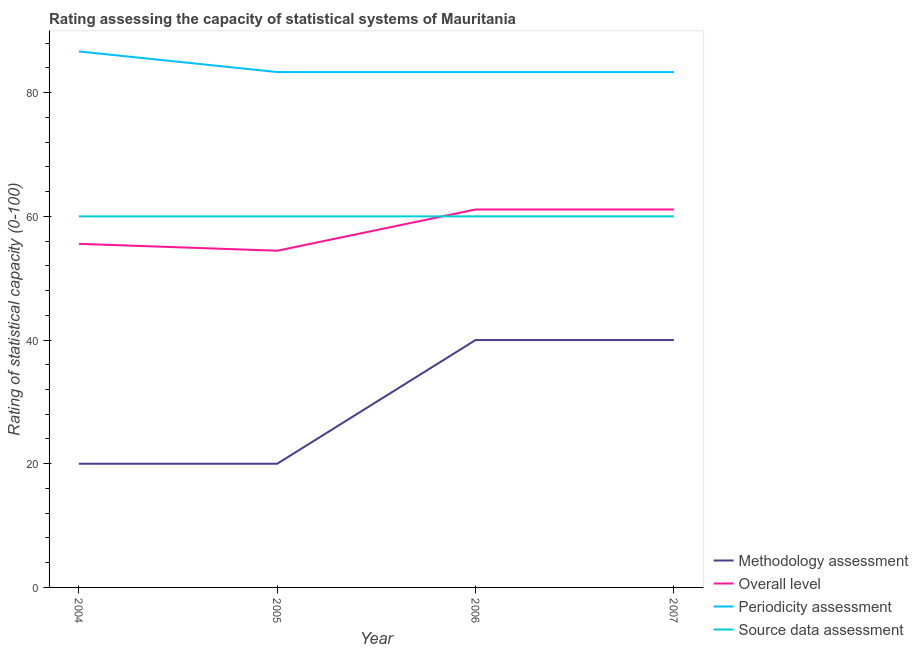How many different coloured lines are there?
Make the answer very short. 4. Does the line corresponding to methodology assessment rating intersect with the line corresponding to periodicity assessment rating?
Keep it short and to the point. No. What is the methodology assessment rating in 2005?
Offer a very short reply. 20. Across all years, what is the maximum source data assessment rating?
Offer a very short reply. 60. Across all years, what is the minimum source data assessment rating?
Your answer should be compact. 60. In which year was the source data assessment rating maximum?
Offer a terse response. 2004. What is the total overall level rating in the graph?
Ensure brevity in your answer.  232.22. What is the difference between the overall level rating in 2004 and that in 2006?
Your response must be concise. -5.56. What is the difference between the periodicity assessment rating in 2006 and the methodology assessment rating in 2005?
Your answer should be compact. 63.33. In the year 2006, what is the difference between the periodicity assessment rating and methodology assessment rating?
Ensure brevity in your answer.  43.33. What is the ratio of the overall level rating in 2005 to that in 2007?
Offer a terse response. 0.89. Is the periodicity assessment rating in 2005 less than that in 2006?
Provide a short and direct response. No. What is the difference between the highest and the second highest overall level rating?
Your response must be concise. 0. In how many years, is the source data assessment rating greater than the average source data assessment rating taken over all years?
Your answer should be compact. 0. Is the sum of the overall level rating in 2004 and 2006 greater than the maximum source data assessment rating across all years?
Your answer should be very brief. Yes. Is it the case that in every year, the sum of the overall level rating and methodology assessment rating is greater than the sum of periodicity assessment rating and source data assessment rating?
Make the answer very short. No. Does the periodicity assessment rating monotonically increase over the years?
Offer a terse response. No. How many lines are there?
Your answer should be very brief. 4. How many years are there in the graph?
Provide a short and direct response. 4. What is the difference between two consecutive major ticks on the Y-axis?
Give a very brief answer. 20. Does the graph contain any zero values?
Your response must be concise. No. Where does the legend appear in the graph?
Your answer should be compact. Bottom right. How many legend labels are there?
Provide a short and direct response. 4. What is the title of the graph?
Provide a short and direct response. Rating assessing the capacity of statistical systems of Mauritania. What is the label or title of the Y-axis?
Your answer should be very brief. Rating of statistical capacity (0-100). What is the Rating of statistical capacity (0-100) in Methodology assessment in 2004?
Ensure brevity in your answer.  20. What is the Rating of statistical capacity (0-100) of Overall level in 2004?
Your answer should be compact. 55.56. What is the Rating of statistical capacity (0-100) in Periodicity assessment in 2004?
Provide a succinct answer. 86.67. What is the Rating of statistical capacity (0-100) of Overall level in 2005?
Offer a very short reply. 54.44. What is the Rating of statistical capacity (0-100) of Periodicity assessment in 2005?
Offer a terse response. 83.33. What is the Rating of statistical capacity (0-100) in Methodology assessment in 2006?
Offer a very short reply. 40. What is the Rating of statistical capacity (0-100) in Overall level in 2006?
Keep it short and to the point. 61.11. What is the Rating of statistical capacity (0-100) in Periodicity assessment in 2006?
Offer a very short reply. 83.33. What is the Rating of statistical capacity (0-100) in Overall level in 2007?
Give a very brief answer. 61.11. What is the Rating of statistical capacity (0-100) in Periodicity assessment in 2007?
Make the answer very short. 83.33. Across all years, what is the maximum Rating of statistical capacity (0-100) of Methodology assessment?
Provide a succinct answer. 40. Across all years, what is the maximum Rating of statistical capacity (0-100) of Overall level?
Provide a short and direct response. 61.11. Across all years, what is the maximum Rating of statistical capacity (0-100) in Periodicity assessment?
Offer a very short reply. 86.67. Across all years, what is the minimum Rating of statistical capacity (0-100) of Methodology assessment?
Ensure brevity in your answer.  20. Across all years, what is the minimum Rating of statistical capacity (0-100) in Overall level?
Offer a very short reply. 54.44. Across all years, what is the minimum Rating of statistical capacity (0-100) in Periodicity assessment?
Offer a very short reply. 83.33. What is the total Rating of statistical capacity (0-100) in Methodology assessment in the graph?
Make the answer very short. 120. What is the total Rating of statistical capacity (0-100) in Overall level in the graph?
Your answer should be very brief. 232.22. What is the total Rating of statistical capacity (0-100) in Periodicity assessment in the graph?
Offer a very short reply. 336.67. What is the total Rating of statistical capacity (0-100) of Source data assessment in the graph?
Offer a terse response. 240. What is the difference between the Rating of statistical capacity (0-100) of Methodology assessment in 2004 and that in 2005?
Provide a short and direct response. 0. What is the difference between the Rating of statistical capacity (0-100) of Periodicity assessment in 2004 and that in 2005?
Make the answer very short. 3.33. What is the difference between the Rating of statistical capacity (0-100) of Methodology assessment in 2004 and that in 2006?
Your answer should be very brief. -20. What is the difference between the Rating of statistical capacity (0-100) of Overall level in 2004 and that in 2006?
Provide a short and direct response. -5.56. What is the difference between the Rating of statistical capacity (0-100) in Periodicity assessment in 2004 and that in 2006?
Ensure brevity in your answer.  3.33. What is the difference between the Rating of statistical capacity (0-100) in Source data assessment in 2004 and that in 2006?
Offer a very short reply. 0. What is the difference between the Rating of statistical capacity (0-100) of Methodology assessment in 2004 and that in 2007?
Provide a short and direct response. -20. What is the difference between the Rating of statistical capacity (0-100) in Overall level in 2004 and that in 2007?
Provide a succinct answer. -5.56. What is the difference between the Rating of statistical capacity (0-100) in Source data assessment in 2004 and that in 2007?
Your response must be concise. 0. What is the difference between the Rating of statistical capacity (0-100) in Methodology assessment in 2005 and that in 2006?
Keep it short and to the point. -20. What is the difference between the Rating of statistical capacity (0-100) in Overall level in 2005 and that in 2006?
Give a very brief answer. -6.67. What is the difference between the Rating of statistical capacity (0-100) in Overall level in 2005 and that in 2007?
Your answer should be compact. -6.67. What is the difference between the Rating of statistical capacity (0-100) in Periodicity assessment in 2005 and that in 2007?
Your response must be concise. 0. What is the difference between the Rating of statistical capacity (0-100) of Methodology assessment in 2006 and that in 2007?
Ensure brevity in your answer.  0. What is the difference between the Rating of statistical capacity (0-100) in Overall level in 2006 and that in 2007?
Offer a terse response. 0. What is the difference between the Rating of statistical capacity (0-100) of Methodology assessment in 2004 and the Rating of statistical capacity (0-100) of Overall level in 2005?
Keep it short and to the point. -34.44. What is the difference between the Rating of statistical capacity (0-100) in Methodology assessment in 2004 and the Rating of statistical capacity (0-100) in Periodicity assessment in 2005?
Give a very brief answer. -63.33. What is the difference between the Rating of statistical capacity (0-100) of Overall level in 2004 and the Rating of statistical capacity (0-100) of Periodicity assessment in 2005?
Provide a short and direct response. -27.78. What is the difference between the Rating of statistical capacity (0-100) of Overall level in 2004 and the Rating of statistical capacity (0-100) of Source data assessment in 2005?
Your answer should be compact. -4.44. What is the difference between the Rating of statistical capacity (0-100) in Periodicity assessment in 2004 and the Rating of statistical capacity (0-100) in Source data assessment in 2005?
Make the answer very short. 26.67. What is the difference between the Rating of statistical capacity (0-100) of Methodology assessment in 2004 and the Rating of statistical capacity (0-100) of Overall level in 2006?
Offer a very short reply. -41.11. What is the difference between the Rating of statistical capacity (0-100) of Methodology assessment in 2004 and the Rating of statistical capacity (0-100) of Periodicity assessment in 2006?
Keep it short and to the point. -63.33. What is the difference between the Rating of statistical capacity (0-100) of Methodology assessment in 2004 and the Rating of statistical capacity (0-100) of Source data assessment in 2006?
Give a very brief answer. -40. What is the difference between the Rating of statistical capacity (0-100) of Overall level in 2004 and the Rating of statistical capacity (0-100) of Periodicity assessment in 2006?
Your response must be concise. -27.78. What is the difference between the Rating of statistical capacity (0-100) of Overall level in 2004 and the Rating of statistical capacity (0-100) of Source data assessment in 2006?
Provide a short and direct response. -4.44. What is the difference between the Rating of statistical capacity (0-100) in Periodicity assessment in 2004 and the Rating of statistical capacity (0-100) in Source data assessment in 2006?
Your answer should be very brief. 26.67. What is the difference between the Rating of statistical capacity (0-100) of Methodology assessment in 2004 and the Rating of statistical capacity (0-100) of Overall level in 2007?
Make the answer very short. -41.11. What is the difference between the Rating of statistical capacity (0-100) of Methodology assessment in 2004 and the Rating of statistical capacity (0-100) of Periodicity assessment in 2007?
Provide a succinct answer. -63.33. What is the difference between the Rating of statistical capacity (0-100) in Overall level in 2004 and the Rating of statistical capacity (0-100) in Periodicity assessment in 2007?
Your answer should be compact. -27.78. What is the difference between the Rating of statistical capacity (0-100) of Overall level in 2004 and the Rating of statistical capacity (0-100) of Source data assessment in 2007?
Your response must be concise. -4.44. What is the difference between the Rating of statistical capacity (0-100) in Periodicity assessment in 2004 and the Rating of statistical capacity (0-100) in Source data assessment in 2007?
Offer a terse response. 26.67. What is the difference between the Rating of statistical capacity (0-100) in Methodology assessment in 2005 and the Rating of statistical capacity (0-100) in Overall level in 2006?
Offer a terse response. -41.11. What is the difference between the Rating of statistical capacity (0-100) in Methodology assessment in 2005 and the Rating of statistical capacity (0-100) in Periodicity assessment in 2006?
Make the answer very short. -63.33. What is the difference between the Rating of statistical capacity (0-100) of Overall level in 2005 and the Rating of statistical capacity (0-100) of Periodicity assessment in 2006?
Give a very brief answer. -28.89. What is the difference between the Rating of statistical capacity (0-100) in Overall level in 2005 and the Rating of statistical capacity (0-100) in Source data assessment in 2006?
Your response must be concise. -5.56. What is the difference between the Rating of statistical capacity (0-100) in Periodicity assessment in 2005 and the Rating of statistical capacity (0-100) in Source data assessment in 2006?
Keep it short and to the point. 23.33. What is the difference between the Rating of statistical capacity (0-100) in Methodology assessment in 2005 and the Rating of statistical capacity (0-100) in Overall level in 2007?
Your response must be concise. -41.11. What is the difference between the Rating of statistical capacity (0-100) in Methodology assessment in 2005 and the Rating of statistical capacity (0-100) in Periodicity assessment in 2007?
Your response must be concise. -63.33. What is the difference between the Rating of statistical capacity (0-100) in Overall level in 2005 and the Rating of statistical capacity (0-100) in Periodicity assessment in 2007?
Your response must be concise. -28.89. What is the difference between the Rating of statistical capacity (0-100) in Overall level in 2005 and the Rating of statistical capacity (0-100) in Source data assessment in 2007?
Offer a very short reply. -5.56. What is the difference between the Rating of statistical capacity (0-100) in Periodicity assessment in 2005 and the Rating of statistical capacity (0-100) in Source data assessment in 2007?
Make the answer very short. 23.33. What is the difference between the Rating of statistical capacity (0-100) in Methodology assessment in 2006 and the Rating of statistical capacity (0-100) in Overall level in 2007?
Your answer should be compact. -21.11. What is the difference between the Rating of statistical capacity (0-100) in Methodology assessment in 2006 and the Rating of statistical capacity (0-100) in Periodicity assessment in 2007?
Provide a short and direct response. -43.33. What is the difference between the Rating of statistical capacity (0-100) in Methodology assessment in 2006 and the Rating of statistical capacity (0-100) in Source data assessment in 2007?
Provide a succinct answer. -20. What is the difference between the Rating of statistical capacity (0-100) of Overall level in 2006 and the Rating of statistical capacity (0-100) of Periodicity assessment in 2007?
Make the answer very short. -22.22. What is the difference between the Rating of statistical capacity (0-100) of Overall level in 2006 and the Rating of statistical capacity (0-100) of Source data assessment in 2007?
Your answer should be very brief. 1.11. What is the difference between the Rating of statistical capacity (0-100) in Periodicity assessment in 2006 and the Rating of statistical capacity (0-100) in Source data assessment in 2007?
Provide a succinct answer. 23.33. What is the average Rating of statistical capacity (0-100) of Overall level per year?
Your answer should be very brief. 58.06. What is the average Rating of statistical capacity (0-100) in Periodicity assessment per year?
Your answer should be very brief. 84.17. In the year 2004, what is the difference between the Rating of statistical capacity (0-100) of Methodology assessment and Rating of statistical capacity (0-100) of Overall level?
Offer a terse response. -35.56. In the year 2004, what is the difference between the Rating of statistical capacity (0-100) of Methodology assessment and Rating of statistical capacity (0-100) of Periodicity assessment?
Your answer should be compact. -66.67. In the year 2004, what is the difference between the Rating of statistical capacity (0-100) in Methodology assessment and Rating of statistical capacity (0-100) in Source data assessment?
Offer a very short reply. -40. In the year 2004, what is the difference between the Rating of statistical capacity (0-100) in Overall level and Rating of statistical capacity (0-100) in Periodicity assessment?
Your response must be concise. -31.11. In the year 2004, what is the difference between the Rating of statistical capacity (0-100) of Overall level and Rating of statistical capacity (0-100) of Source data assessment?
Offer a terse response. -4.44. In the year 2004, what is the difference between the Rating of statistical capacity (0-100) of Periodicity assessment and Rating of statistical capacity (0-100) of Source data assessment?
Provide a succinct answer. 26.67. In the year 2005, what is the difference between the Rating of statistical capacity (0-100) of Methodology assessment and Rating of statistical capacity (0-100) of Overall level?
Your answer should be very brief. -34.44. In the year 2005, what is the difference between the Rating of statistical capacity (0-100) in Methodology assessment and Rating of statistical capacity (0-100) in Periodicity assessment?
Your response must be concise. -63.33. In the year 2005, what is the difference between the Rating of statistical capacity (0-100) of Overall level and Rating of statistical capacity (0-100) of Periodicity assessment?
Your answer should be very brief. -28.89. In the year 2005, what is the difference between the Rating of statistical capacity (0-100) in Overall level and Rating of statistical capacity (0-100) in Source data assessment?
Ensure brevity in your answer.  -5.56. In the year 2005, what is the difference between the Rating of statistical capacity (0-100) of Periodicity assessment and Rating of statistical capacity (0-100) of Source data assessment?
Keep it short and to the point. 23.33. In the year 2006, what is the difference between the Rating of statistical capacity (0-100) in Methodology assessment and Rating of statistical capacity (0-100) in Overall level?
Keep it short and to the point. -21.11. In the year 2006, what is the difference between the Rating of statistical capacity (0-100) of Methodology assessment and Rating of statistical capacity (0-100) of Periodicity assessment?
Provide a succinct answer. -43.33. In the year 2006, what is the difference between the Rating of statistical capacity (0-100) of Methodology assessment and Rating of statistical capacity (0-100) of Source data assessment?
Keep it short and to the point. -20. In the year 2006, what is the difference between the Rating of statistical capacity (0-100) of Overall level and Rating of statistical capacity (0-100) of Periodicity assessment?
Make the answer very short. -22.22. In the year 2006, what is the difference between the Rating of statistical capacity (0-100) in Overall level and Rating of statistical capacity (0-100) in Source data assessment?
Keep it short and to the point. 1.11. In the year 2006, what is the difference between the Rating of statistical capacity (0-100) in Periodicity assessment and Rating of statistical capacity (0-100) in Source data assessment?
Give a very brief answer. 23.33. In the year 2007, what is the difference between the Rating of statistical capacity (0-100) in Methodology assessment and Rating of statistical capacity (0-100) in Overall level?
Ensure brevity in your answer.  -21.11. In the year 2007, what is the difference between the Rating of statistical capacity (0-100) of Methodology assessment and Rating of statistical capacity (0-100) of Periodicity assessment?
Give a very brief answer. -43.33. In the year 2007, what is the difference between the Rating of statistical capacity (0-100) in Methodology assessment and Rating of statistical capacity (0-100) in Source data assessment?
Your response must be concise. -20. In the year 2007, what is the difference between the Rating of statistical capacity (0-100) in Overall level and Rating of statistical capacity (0-100) in Periodicity assessment?
Your response must be concise. -22.22. In the year 2007, what is the difference between the Rating of statistical capacity (0-100) in Periodicity assessment and Rating of statistical capacity (0-100) in Source data assessment?
Your answer should be compact. 23.33. What is the ratio of the Rating of statistical capacity (0-100) of Overall level in 2004 to that in 2005?
Offer a very short reply. 1.02. What is the ratio of the Rating of statistical capacity (0-100) of Periodicity assessment in 2004 to that in 2005?
Your answer should be compact. 1.04. What is the ratio of the Rating of statistical capacity (0-100) in Methodology assessment in 2004 to that in 2006?
Your answer should be compact. 0.5. What is the ratio of the Rating of statistical capacity (0-100) of Source data assessment in 2004 to that in 2006?
Provide a short and direct response. 1. What is the ratio of the Rating of statistical capacity (0-100) of Methodology assessment in 2004 to that in 2007?
Ensure brevity in your answer.  0.5. What is the ratio of the Rating of statistical capacity (0-100) of Periodicity assessment in 2004 to that in 2007?
Make the answer very short. 1.04. What is the ratio of the Rating of statistical capacity (0-100) in Source data assessment in 2004 to that in 2007?
Your response must be concise. 1. What is the ratio of the Rating of statistical capacity (0-100) in Overall level in 2005 to that in 2006?
Offer a very short reply. 0.89. What is the ratio of the Rating of statistical capacity (0-100) of Source data assessment in 2005 to that in 2006?
Your answer should be compact. 1. What is the ratio of the Rating of statistical capacity (0-100) in Overall level in 2005 to that in 2007?
Keep it short and to the point. 0.89. What is the ratio of the Rating of statistical capacity (0-100) of Periodicity assessment in 2005 to that in 2007?
Your response must be concise. 1. What is the ratio of the Rating of statistical capacity (0-100) in Source data assessment in 2005 to that in 2007?
Provide a short and direct response. 1. What is the ratio of the Rating of statistical capacity (0-100) of Methodology assessment in 2006 to that in 2007?
Keep it short and to the point. 1. What is the ratio of the Rating of statistical capacity (0-100) in Overall level in 2006 to that in 2007?
Provide a short and direct response. 1. What is the ratio of the Rating of statistical capacity (0-100) of Source data assessment in 2006 to that in 2007?
Your answer should be compact. 1. What is the difference between the highest and the second highest Rating of statistical capacity (0-100) in Overall level?
Your response must be concise. 0. What is the difference between the highest and the second highest Rating of statistical capacity (0-100) in Source data assessment?
Provide a succinct answer. 0. What is the difference between the highest and the lowest Rating of statistical capacity (0-100) of Overall level?
Your answer should be very brief. 6.67. 